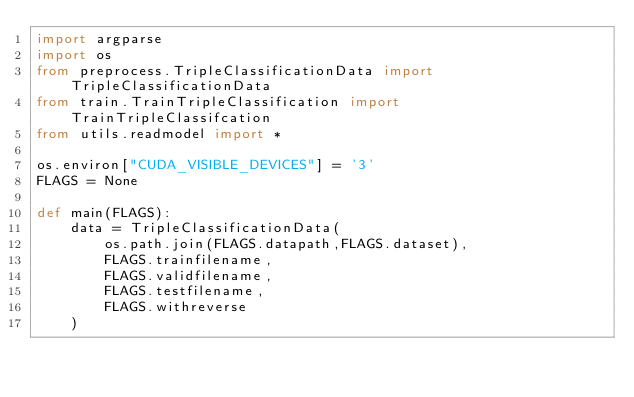<code> <loc_0><loc_0><loc_500><loc_500><_Python_>import argparse
import os
from preprocess.TripleClassificationData import TripleClassificationData
from train.TrainTripleClassification import TrainTripleClassifcation
from utils.readmodel import *

os.environ["CUDA_VISIBLE_DEVICES"] = '3'
FLAGS = None

def main(FLAGS):
    data = TripleClassificationData(
        os.path.join(FLAGS.datapath,FLAGS.dataset),
        FLAGS.trainfilename,
        FLAGS.validfilename,
        FLAGS.testfilename,
        FLAGS.withreverse
    )
</code> 